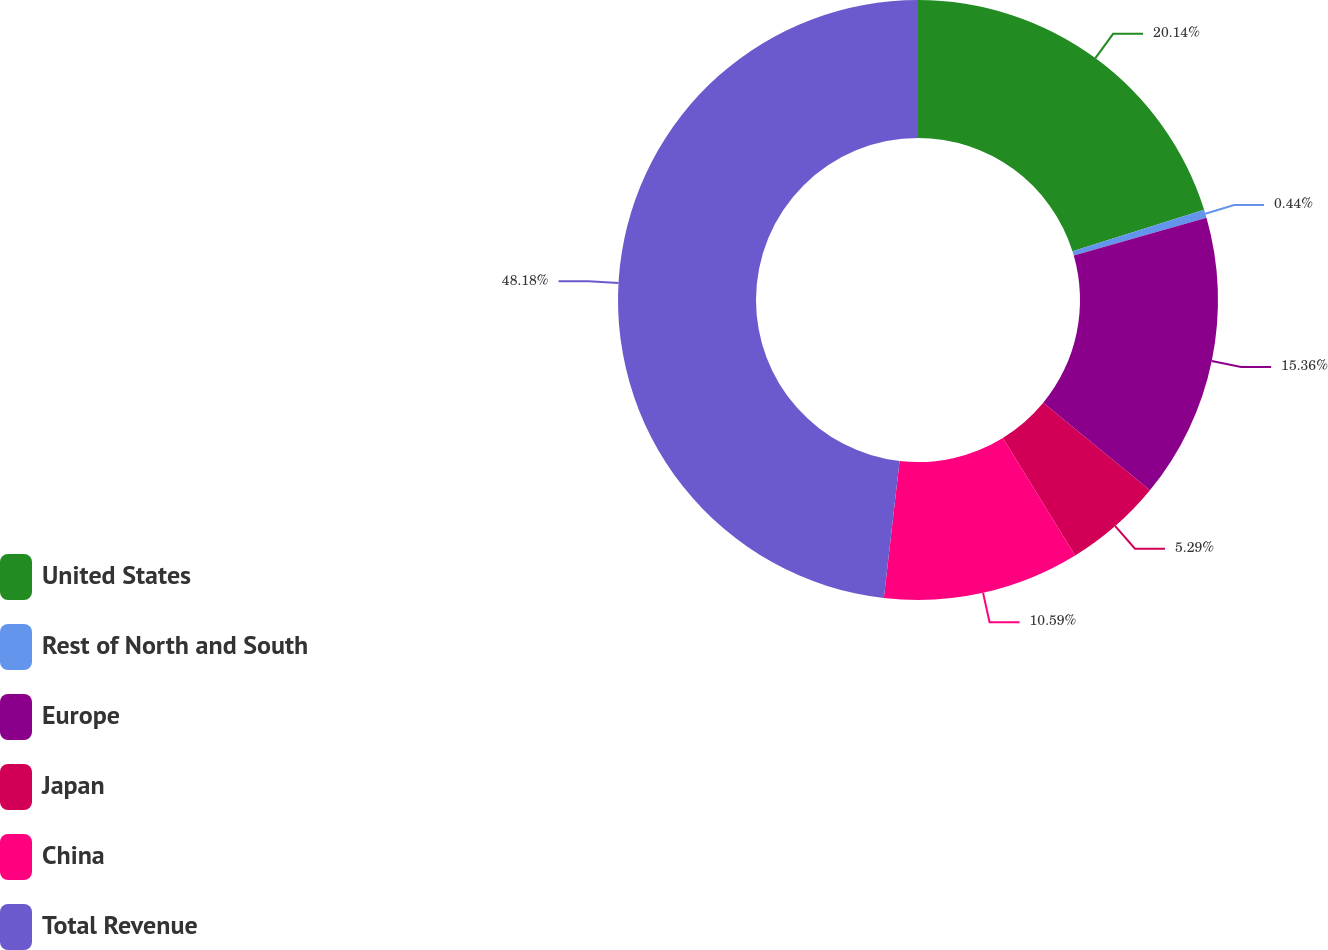Convert chart to OTSL. <chart><loc_0><loc_0><loc_500><loc_500><pie_chart><fcel>United States<fcel>Rest of North and South<fcel>Europe<fcel>Japan<fcel>China<fcel>Total Revenue<nl><fcel>20.14%<fcel>0.44%<fcel>15.36%<fcel>5.29%<fcel>10.59%<fcel>48.19%<nl></chart> 